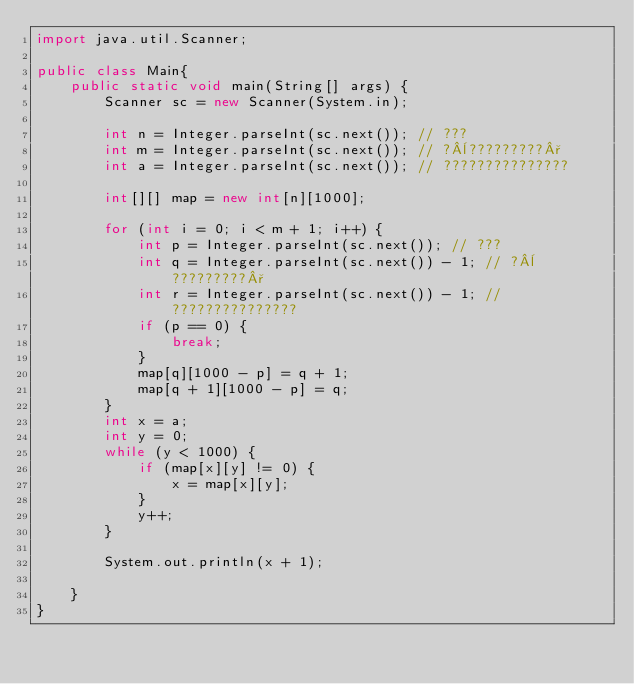<code> <loc_0><loc_0><loc_500><loc_500><_Java_>import java.util.Scanner;

public class Main{
	public static void main(String[] args) {
		Scanner sc = new Scanner(System.in);

		int n = Integer.parseInt(sc.next()); // ???
		int m = Integer.parseInt(sc.next()); // ?¨?????????°
		int a = Integer.parseInt(sc.next()); // ???????????????

		int[][] map = new int[n][1000];

		for (int i = 0; i < m + 1; i++) {
			int p = Integer.parseInt(sc.next()); // ???
			int q = Integer.parseInt(sc.next()) - 1; // ?¨?????????°
			int r = Integer.parseInt(sc.next()) - 1; // ???????????????
			if (p == 0) {
				break;
			}
			map[q][1000 - p] = q + 1;
			map[q + 1][1000 - p] = q;
		}
		int x = a;
		int y = 0;
		while (y < 1000) {
			if (map[x][y] != 0) {
				x = map[x][y];
			}
			y++;
		}

		System.out.println(x + 1);

	}
}</code> 